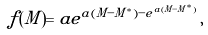<formula> <loc_0><loc_0><loc_500><loc_500>f ( M ) = a e ^ { a ( M - M ^ { * } ) - e ^ { a ( M - M ^ { * } ) } } \, ,</formula> 